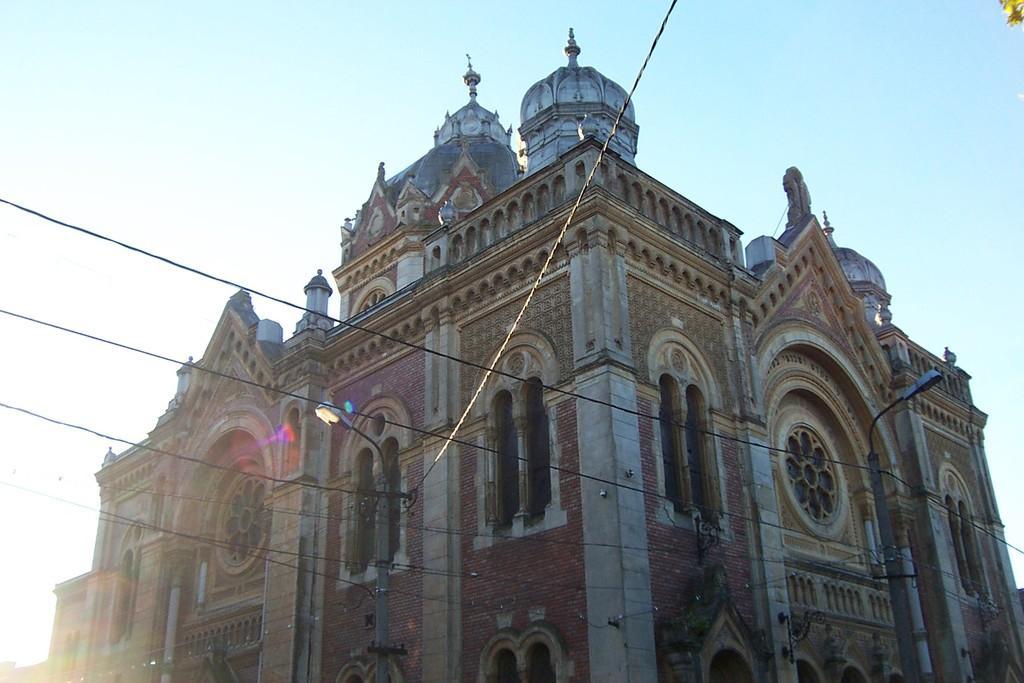Could you give a brief overview of what you see in this image? In this image we can see a building, light poles, wires. At the top of the image there is sky. 